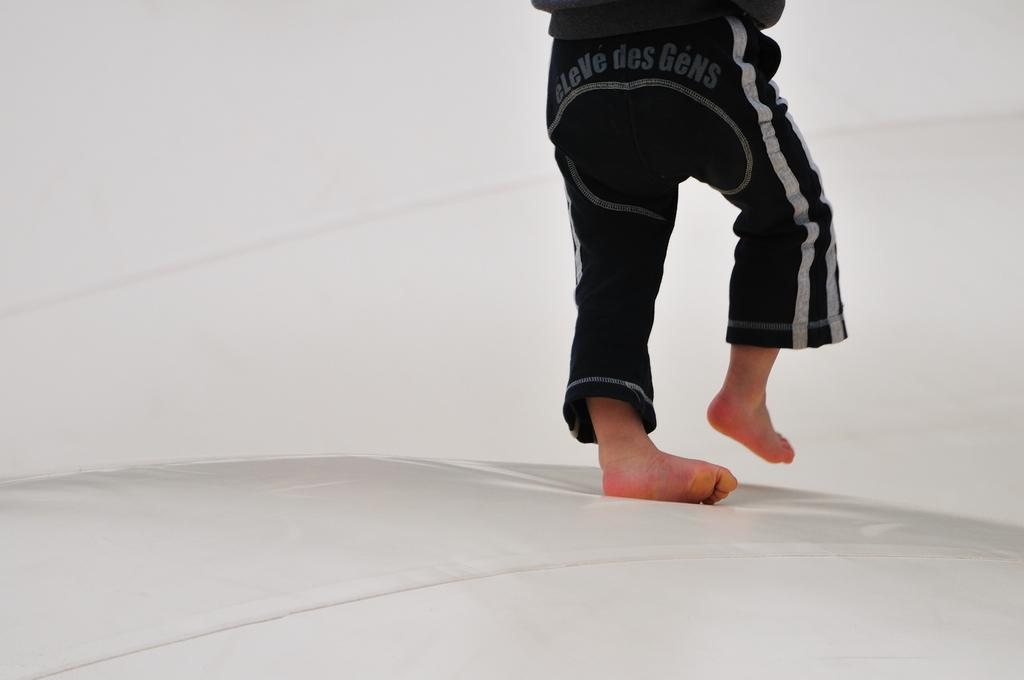Who is present in the image? There is a person in the image. What is the person wearing? The person is wearing a black dress. What is the person doing in the image? The person is walking on a white surface. What is the color of the background in the image? The background of the image is white. How many pickles can be seen in the image? There are no pickles present in the image. What type of support is the person using to walk in the image? The person is walking on a white surface without any visible support. 